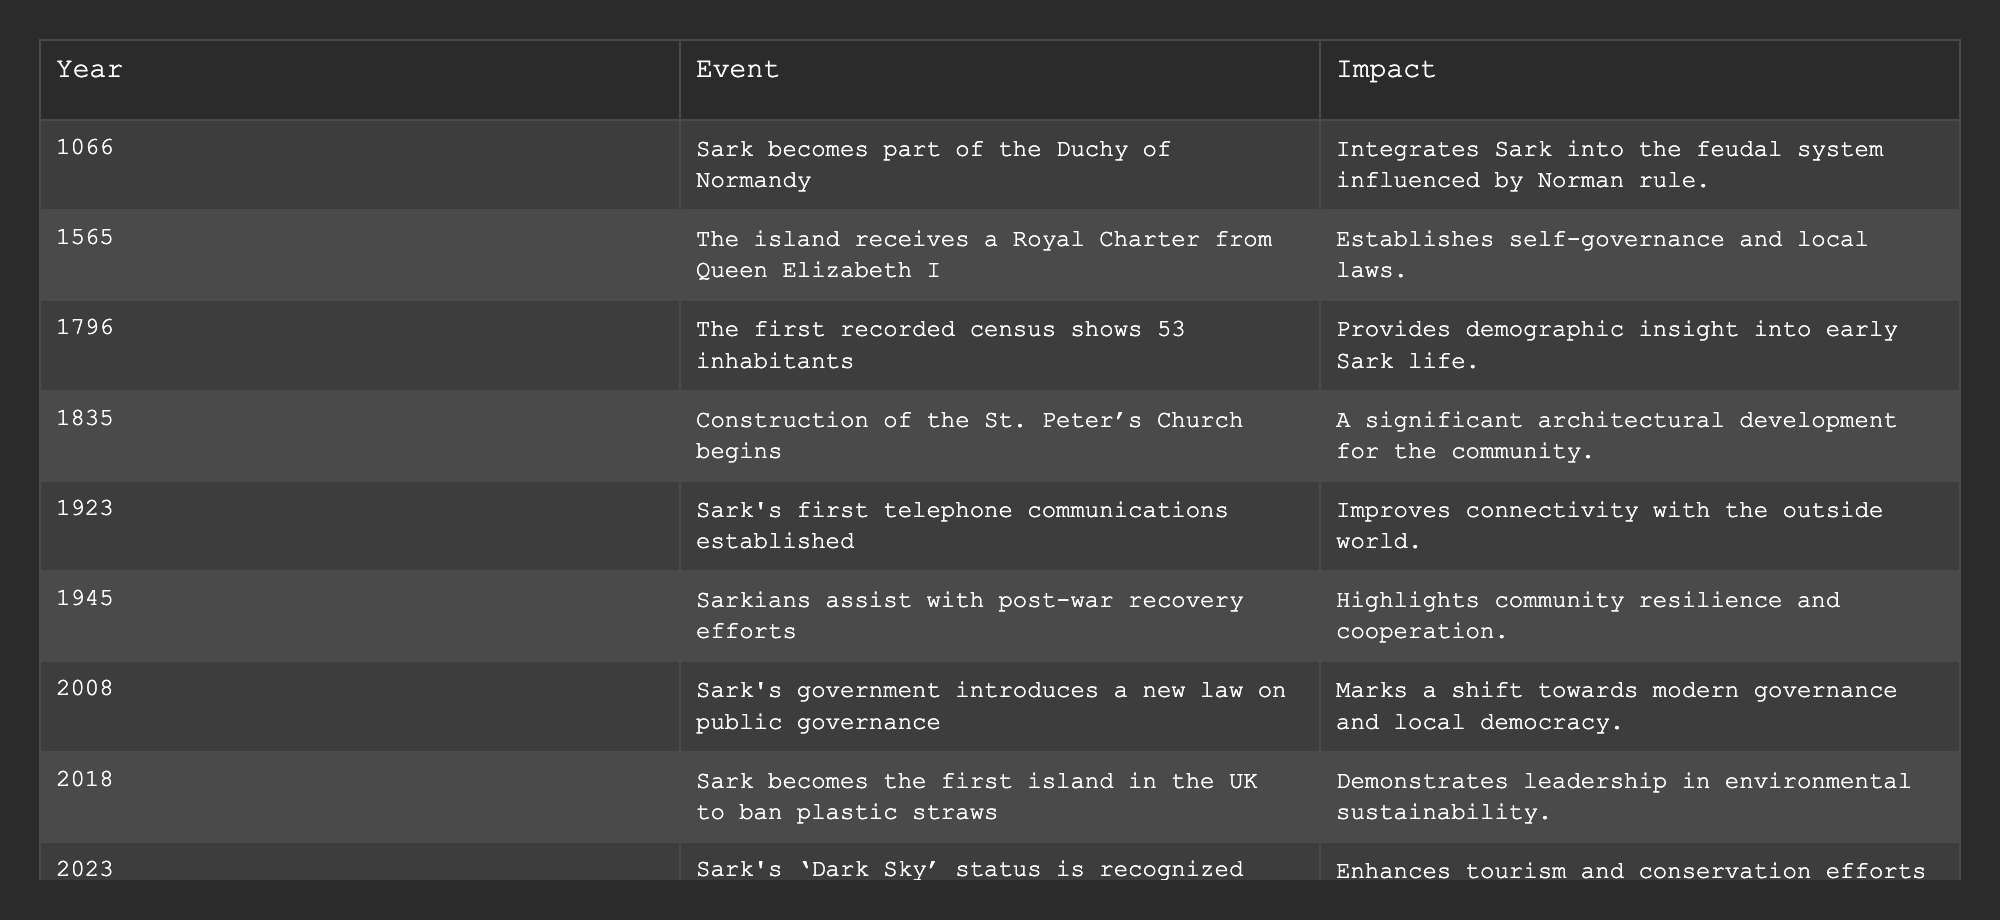What year did Sark receive a Royal Charter from Queen Elizabeth I? The table lists significant events in Sark's history with their respective years. From the event describing the Royal Charter from Queen Elizabeth I, it is noted that this occurred in the year 1565.
Answer: 1565 What event shows the first population count in Sark? The table indicates that the first recorded census showing 53 inhabitants occurred in the year 1796. This is the event directly related to the initial population count on the island.
Answer: The first recorded census In which year did Sark's government introduce a new law on public governance? Referring to the table, the new law on public governance by Sark's government is recorded as taking place in the year 2008.
Answer: 2008 How many significant events listed occurred before the year 1900? By reviewing the table, the events before 1900 are: 1066, 1565, 1796, and 1835. This totals to four significant events.
Answer: 4 Was there an event related to telecommunications in Sark? The table lists an event from the year 1923 that states Sark's first telephone communications were established, indicating that there was indeed an event relating to telecommunications.
Answer: Yes What is the impact of Sark becoming part of the Duchy of Normandy? According to the table, the impact of this event in 1066 was that it integrated Sark into the feudal system influenced by Norman rule.
Answer: Integrated into the feudal system Calculate the number of years between when Sark became part of the Duchy of Normandy and when the island received a Royal Charter. The year when Sark became part of the Duchy of Normandy is 1066, and the Royal Charter was received in 1565. The difference in years is 1565 - 1066 = 499 years.
Answer: 499 years Which event marks a shift towards modern governance? The table highlights the introduction of a new law on public governance in 2008 as a significant event that marks a shift towards modern governance in Sark.
Answer: New law on public governance in 2008 Identify the most recent event listed in the table and its year. The last event recorded in the table is Sark's 'Dark Sky' status being recognized, which occurred in the year 2023.
Answer: 2023 What major environmental action did Sark take in 2018? The table notes that in 2018, Sark became the first island in the UK to ban plastic straws, marking a significant environmental initiative.
Answer: Ban on plastic straws 